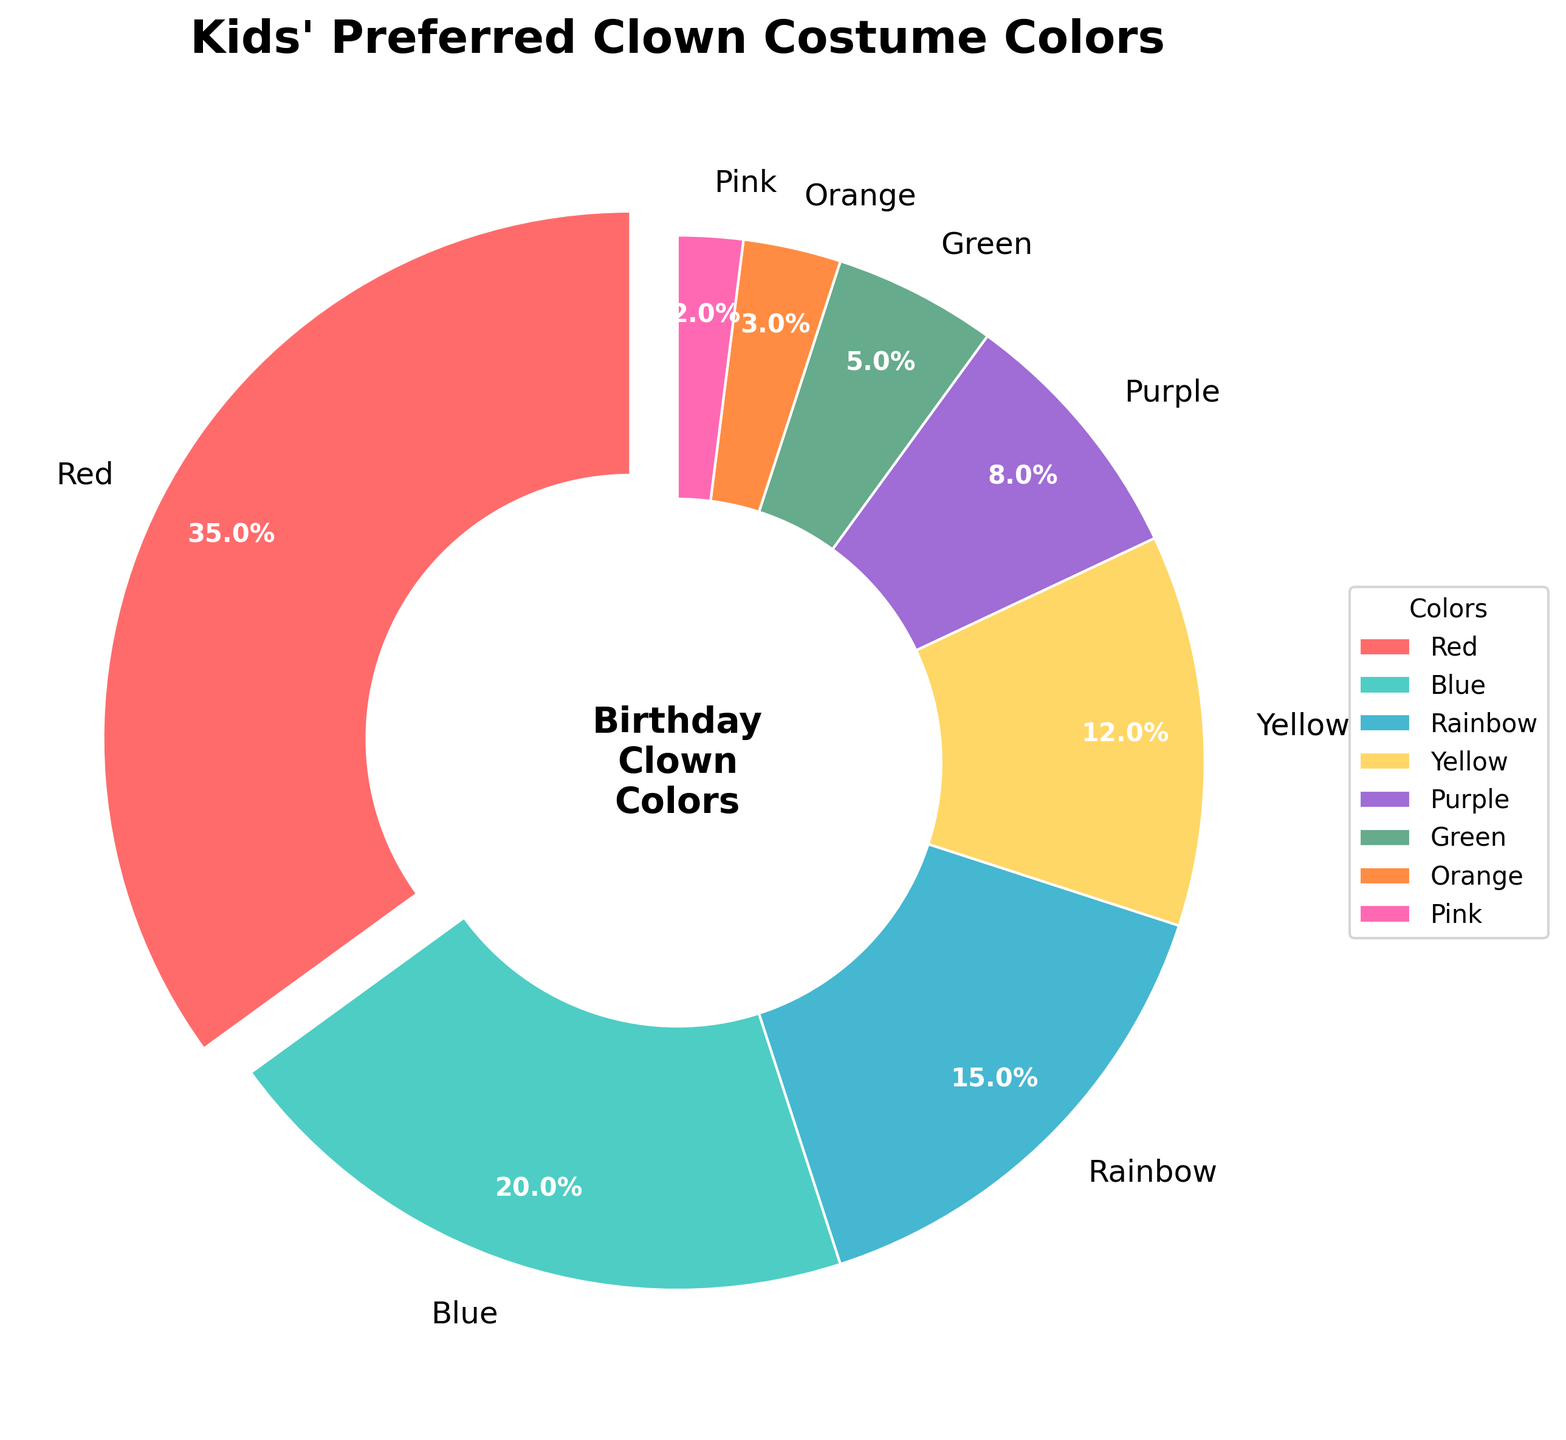Which color is preferred by the most kids? The largest slice in the pie chart and the one with the highest percentage label represents the most preferred color by the kids. The chart shows that the red section is the largest, indicating it is preferred by 35% of the kids.
Answer: Red What is the total percentage for rainbow-colored and yellow costumes combined? Look at the percentages for rainbow (15%) and yellow (12%) costumes on the pie chart, then add them up: 15% + 12% = 27%.
Answer: 27% Is the percentage of kids who prefer purple or green higher than the percentage for blue? The percentage for purple is 8%, and the percentage for green is 5%. Adding these gives 8% + 5% = 13%. The percentage of kids who prefer blue is 20%. Since 13% is less than 20%, the combined preference for purple or green is not higher than blue.
Answer: No Which colors have less than 10% preference? From the chart, the sections representing less than 10% are purple (8%), green (5%), orange (3%), and pink (2%).
Answer: Purple, Green, Orange, Pink How much more do kids prefer red costumes compared to green costumes? The percentage for red is 35%, and for green, it is 5%. Subtracting these values gives: 35% - 5% = 30%.
Answer: 30% What is the combined preference percentage for blue, yellow, and purple? Add the percentages for blue (20%), yellow (12%), and purple (8%): 20% + 12% + 8% = 40%.
Answer: 40% Which slice has the smallest percentage, and what is it? The smallest slice in the pie chart is the pink section, with a percentage label of 2%.
Answer: Pink, 2% Are there any colors tied in preference? Looking at the chart, none of the color percentages are the same. Each percentage is unique.
Answer: No How does the percentage preference for rainbow compare to yellow? The percentage preference for rainbow is 15%, and for yellow, it is 12%. Since 15% is greater than 12%, kids prefer rainbow more than yellow.
Answer: Rainbow is preferred more than yellow What percentage of kids prefer either orange or pink costumes? Adding the percentages for orange (3%) and pink (2%): 3% + 2% = 5%.
Answer: 5% 